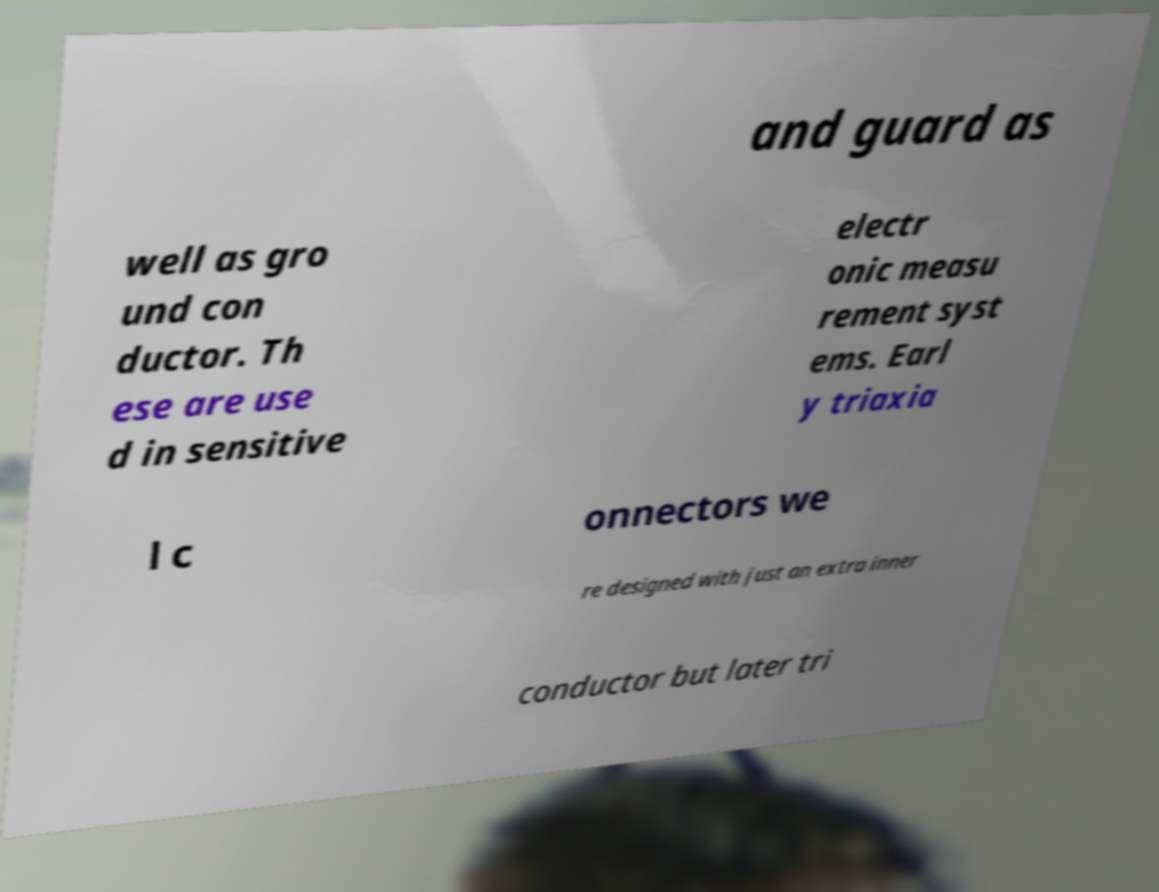Could you assist in decoding the text presented in this image and type it out clearly? and guard as well as gro und con ductor. Th ese are use d in sensitive electr onic measu rement syst ems. Earl y triaxia l c onnectors we re designed with just an extra inner conductor but later tri 